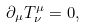<formula> <loc_0><loc_0><loc_500><loc_500>\partial _ { \mu } T _ { \nu } ^ { \mu } = 0 ,</formula> 